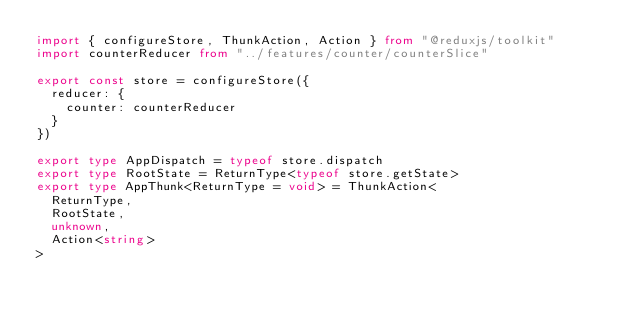<code> <loc_0><loc_0><loc_500><loc_500><_TypeScript_>import { configureStore, ThunkAction, Action } from "@reduxjs/toolkit"
import counterReducer from "../features/counter/counterSlice"

export const store = configureStore({
  reducer: {
    counter: counterReducer
  }
})

export type AppDispatch = typeof store.dispatch
export type RootState = ReturnType<typeof store.getState>
export type AppThunk<ReturnType = void> = ThunkAction<
  ReturnType,
  RootState,
  unknown,
  Action<string>
>
</code> 